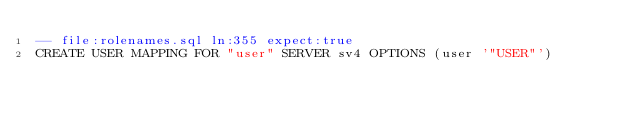Convert code to text. <code><loc_0><loc_0><loc_500><loc_500><_SQL_>-- file:rolenames.sql ln:355 expect:true
CREATE USER MAPPING FOR "user" SERVER sv4 OPTIONS (user '"USER"')
</code> 